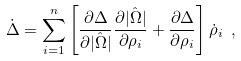Convert formula to latex. <formula><loc_0><loc_0><loc_500><loc_500>\dot { \Delta } = \sum _ { i = 1 } ^ { n } \left [ \frac { \partial \Delta } { \partial | \hat { \Omega } | } \frac { \partial | \hat { \Omega } | } { \partial \rho _ { i } } + \frac { \partial \Delta } { \partial \rho _ { i } } \right ] \dot { \rho } _ { i } \ ,</formula> 